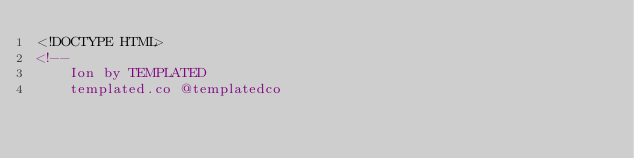<code> <loc_0><loc_0><loc_500><loc_500><_HTML_><!DOCTYPE HTML>
<!--
	Ion by TEMPLATED
	templated.co @templatedco</code> 